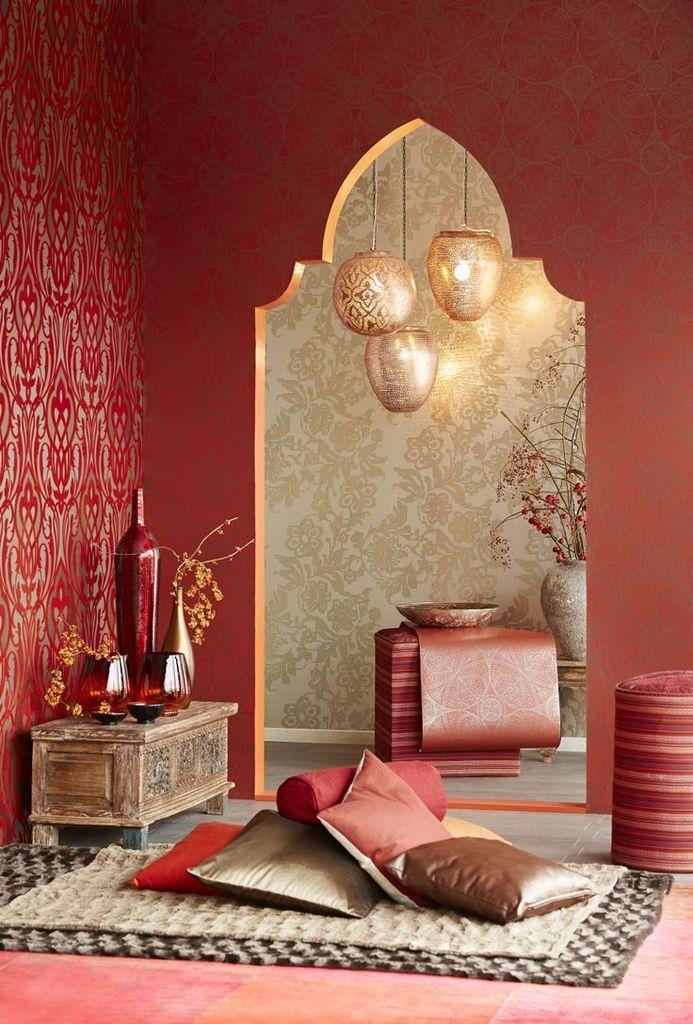Can you describe this image briefly? In this picture we can see pillows and bed sheets at the bottom, on the left side there is a wall and a table, we can see flower vases on the table, in the background there is a plant, a pot, a bowl and lights. 